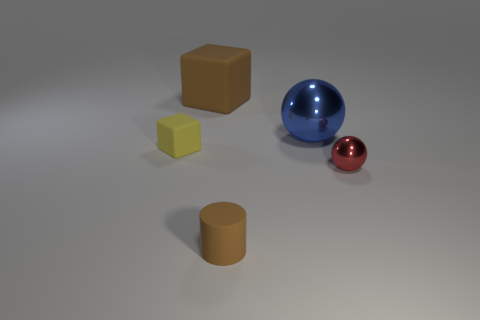Do the cube that is right of the tiny yellow matte thing and the matte object that is in front of the tiny yellow cube have the same color?
Give a very brief answer. Yes. There is a thing that is left of the large shiny sphere and in front of the yellow object; what color is it?
Your answer should be very brief. Brown. Do the small brown object and the tiny ball have the same material?
Offer a terse response. No. How many tiny objects are either shiny cylinders or brown cylinders?
Your answer should be very brief. 1. Is there anything else that has the same shape as the small brown thing?
Ensure brevity in your answer.  No. There is a large cube that is made of the same material as the small block; what color is it?
Ensure brevity in your answer.  Brown. What color is the cube that is behind the yellow object?
Make the answer very short. Brown. How many rubber things have the same color as the matte cylinder?
Ensure brevity in your answer.  1. Are there fewer blue metal spheres behind the large brown cube than things to the right of the big shiny sphere?
Offer a very short reply. Yes. There is a rubber cylinder; how many tiny cylinders are to the right of it?
Offer a terse response. 0. 